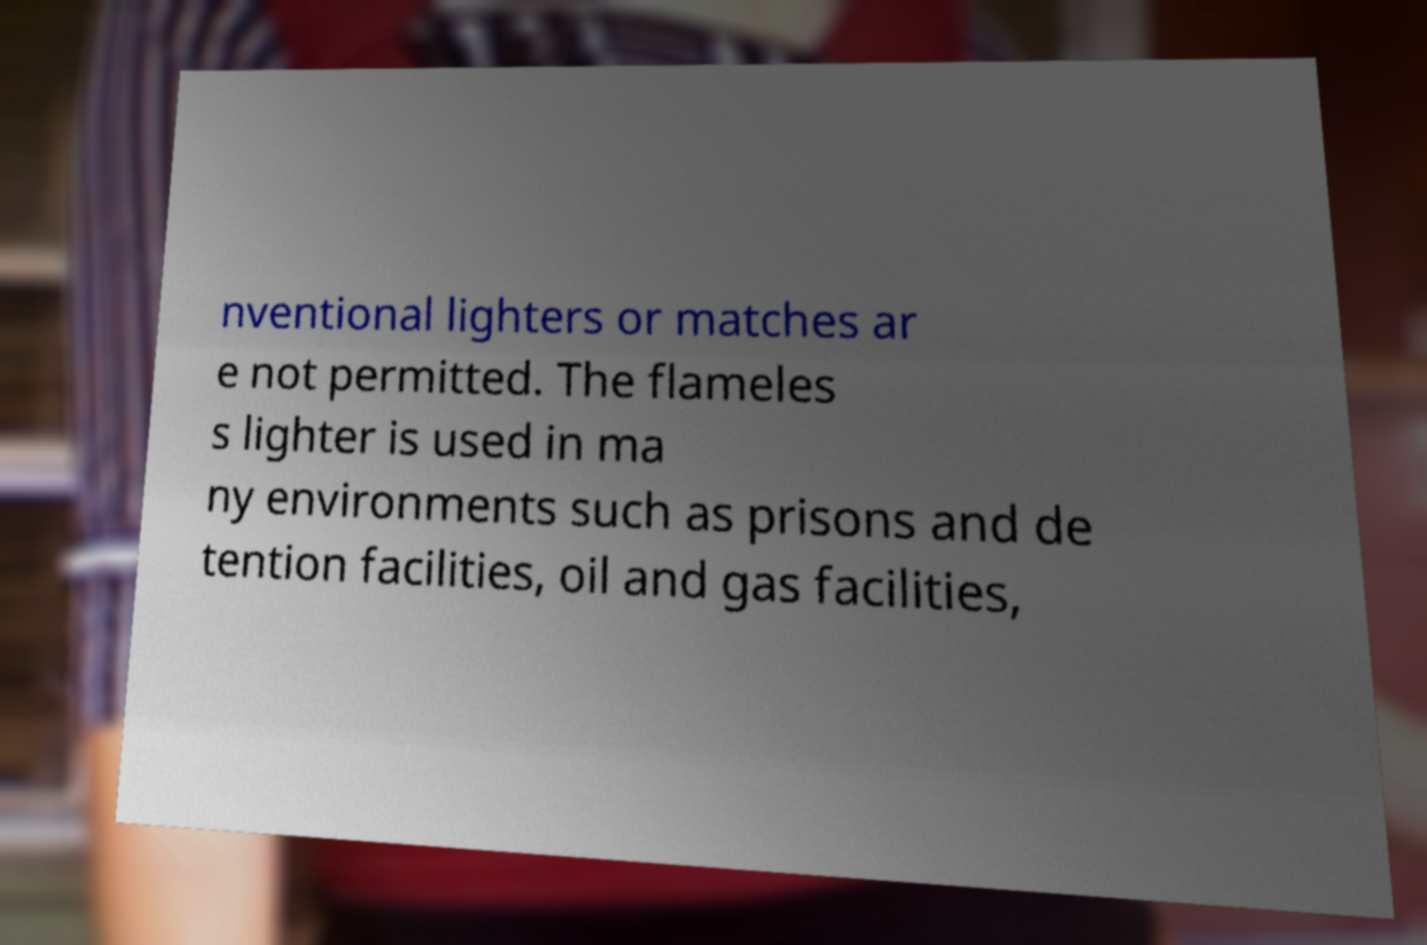For documentation purposes, I need the text within this image transcribed. Could you provide that? nventional lighters or matches ar e not permitted. The flameles s lighter is used in ma ny environments such as prisons and de tention facilities, oil and gas facilities, 